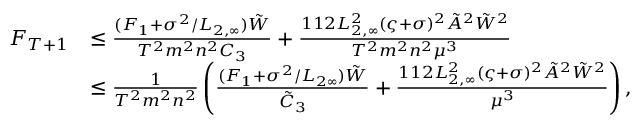Convert formula to latex. <formula><loc_0><loc_0><loc_500><loc_500>\begin{array} { r l } { F _ { T + 1 } } & { \leq \frac { ( F _ { 1 } + \sigma ^ { 2 } / L _ { 2 , \infty } ) \tilde { W } } { T ^ { 2 } m ^ { 2 } n ^ { 2 } C _ { 3 } } + \frac { 1 1 2 L _ { 2 , \infty } ^ { 2 } ( \varsigma + \sigma ) ^ { 2 } \tilde { A } ^ { 2 } \tilde { W } ^ { 2 } } { T ^ { 2 } m ^ { 2 } n ^ { 2 } \mu ^ { 3 } } } \\ & { \leq \frac { 1 } { T ^ { 2 } m ^ { 2 } n ^ { 2 } } \left ( \frac { ( F _ { 1 } + \sigma ^ { 2 } / L _ { 2 \infty } ) \tilde { W } } { \tilde { C } _ { 3 } } + \frac { 1 1 2 L _ { 2 , \infty } ^ { 2 } ( \varsigma + \sigma ) ^ { 2 } \tilde { A } ^ { 2 } \tilde { W } ^ { 2 } } { \mu ^ { 3 } } \right ) , } \end{array}</formula> 